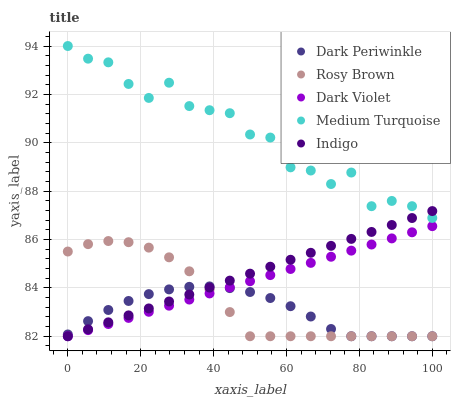Does Dark Periwinkle have the minimum area under the curve?
Answer yes or no. Yes. Does Medium Turquoise have the maximum area under the curve?
Answer yes or no. Yes. Does Rosy Brown have the minimum area under the curve?
Answer yes or no. No. Does Rosy Brown have the maximum area under the curve?
Answer yes or no. No. Is Indigo the smoothest?
Answer yes or no. Yes. Is Medium Turquoise the roughest?
Answer yes or no. Yes. Is Rosy Brown the smoothest?
Answer yes or no. No. Is Rosy Brown the roughest?
Answer yes or no. No. Does Rosy Brown have the lowest value?
Answer yes or no. Yes. Does Medium Turquoise have the highest value?
Answer yes or no. Yes. Does Rosy Brown have the highest value?
Answer yes or no. No. Is Dark Violet less than Medium Turquoise?
Answer yes or no. Yes. Is Medium Turquoise greater than Dark Periwinkle?
Answer yes or no. Yes. Does Dark Periwinkle intersect Rosy Brown?
Answer yes or no. Yes. Is Dark Periwinkle less than Rosy Brown?
Answer yes or no. No. Is Dark Periwinkle greater than Rosy Brown?
Answer yes or no. No. Does Dark Violet intersect Medium Turquoise?
Answer yes or no. No. 